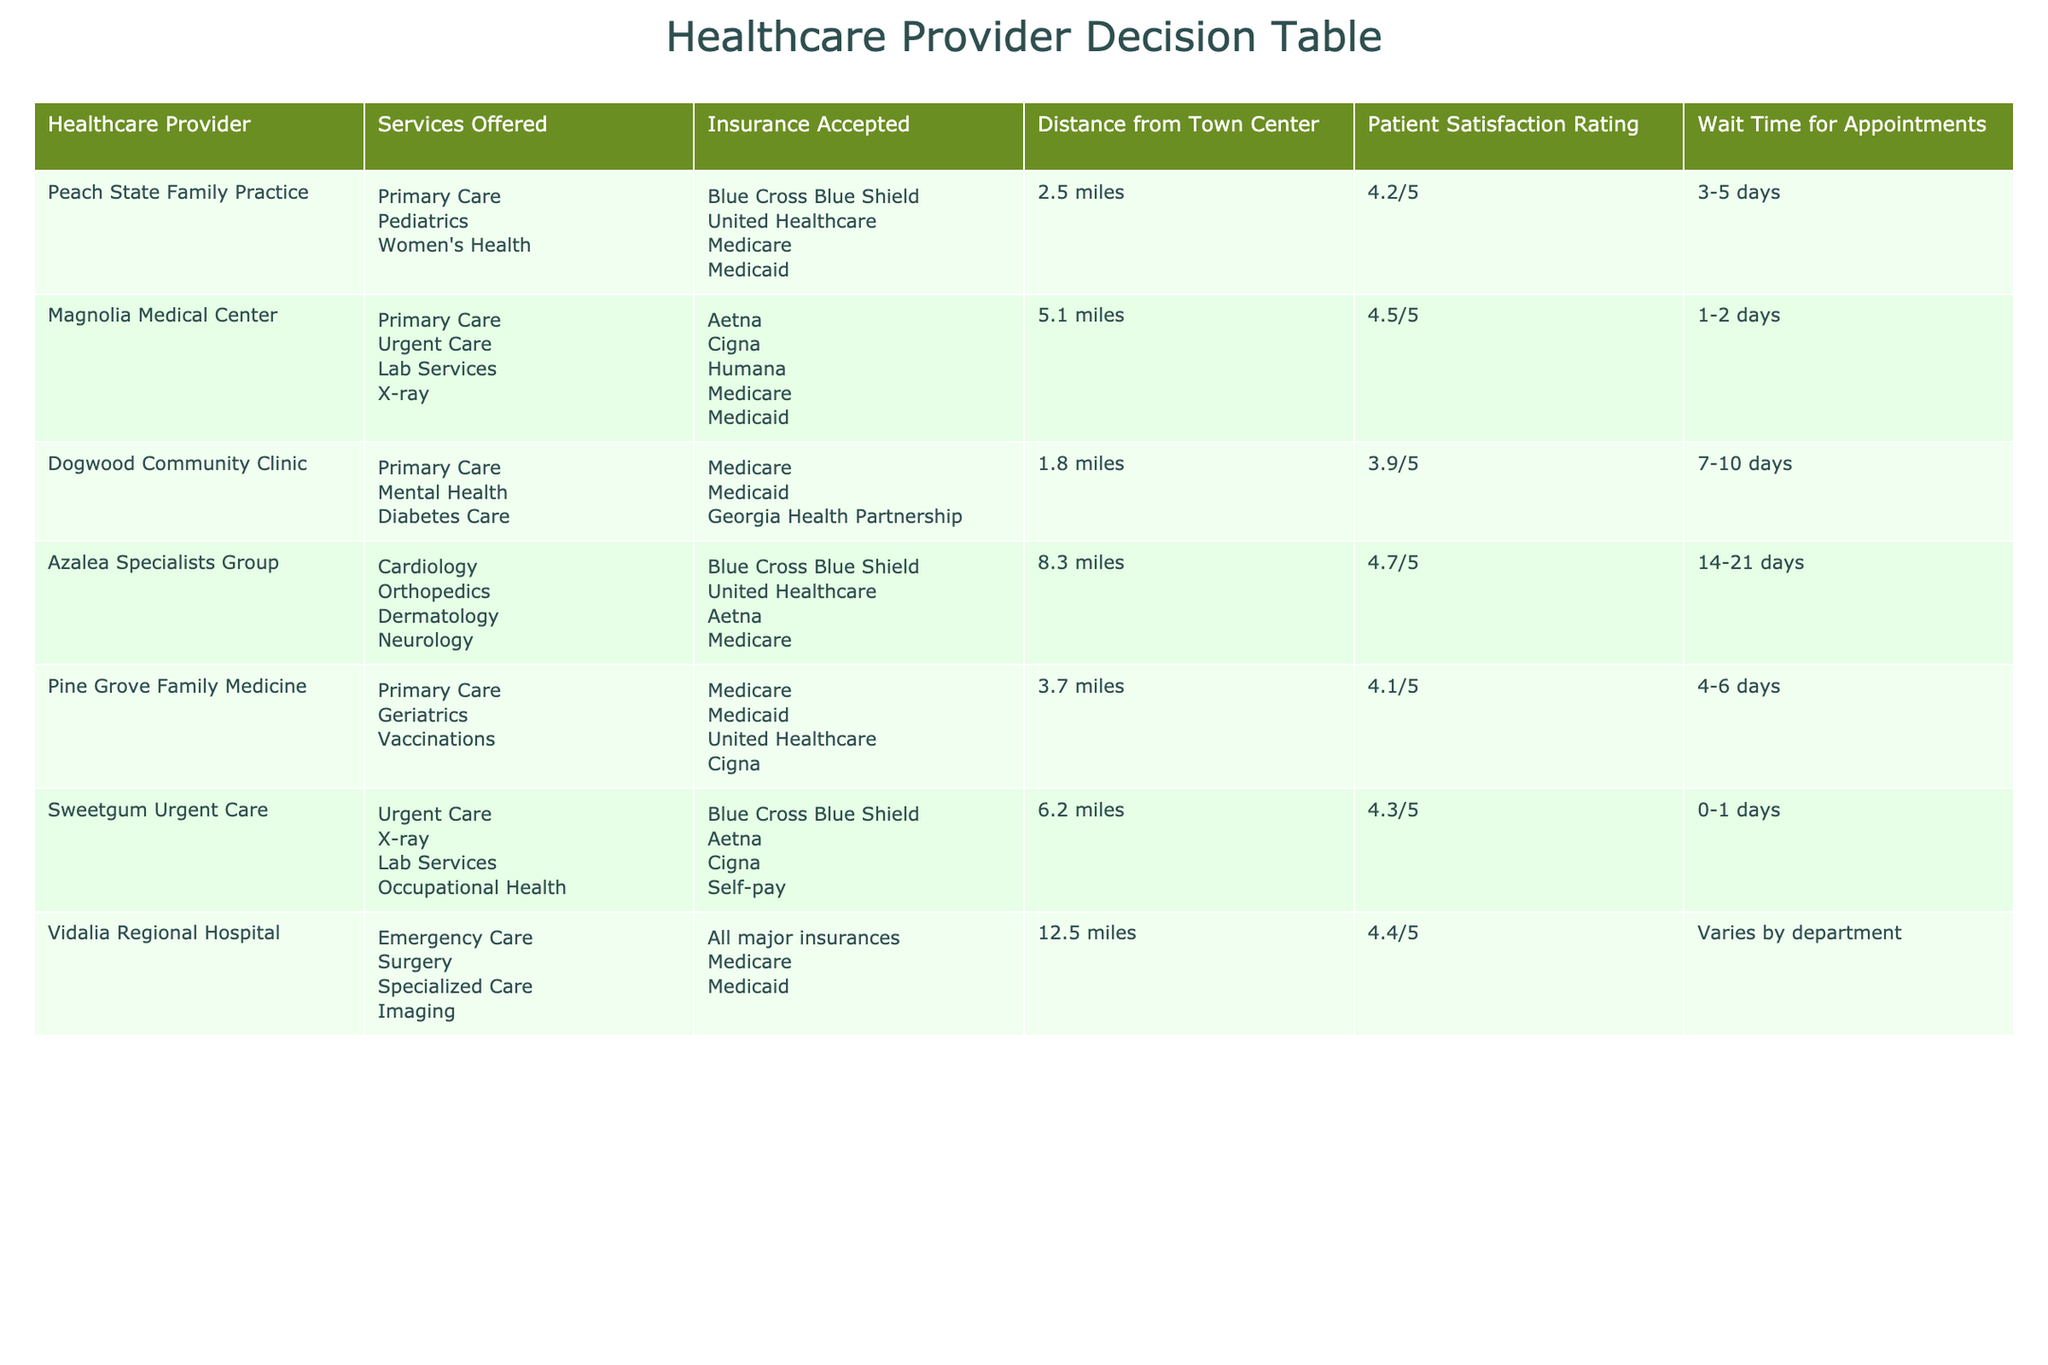What is the distance from Peach State Family Practice to the town center? The table lists the distance from the town center for each healthcare provider. For Peach State Family Practice, the distance is shown as 2.5 miles.
Answer: 2.5 miles Which provider has the highest patient satisfaction rating? The table includes ratings for patient satisfaction. Upon comparing the ratings, Azalea Specialists Group has the highest rating at 4.7/5.
Answer: Azalea Specialists Group How many healthcare providers accept Medicare? By reviewing the 'Insurance Accepted' column, we can count how many providers list Medicare among their accepted insurances. The providers that accept Medicare are: Magnolia Medical Center, Dogwood Community Clinic, Pine Grove Family Medicine, Azalea Specialists Group, Sweetgum Urgent Care, and Vidalia Regional Hospital, totaling 6 providers.
Answer: 6 Is there a provider that offers urgent care services within 5 miles of the town center? To answer this, we check the services offered and the distance from the town center for each provider. Magnolia Medical Center and Sweetgum Urgent Care both offer urgent care services and are located within 5 miles. Thus, the answer is yes.
Answer: Yes What is the average wait time for appointments among the providers? First, identify the wait times from the table: Peach State Family Practice (3-5 days), Magnolia Medical Center (1-2 days), Dogwood Community Clinic (7-10 days), Pine Grove Family Medicine (4-6 days), Sweetgum Urgent Care (0-1 days), and Vidalia Regional Hospital (varies). Estimate the average wait time by taking the midpoint of each range: 4 days, 1.5 days, 8.5 days, 5 days, 0.5 days, and an assumed midpoint (for variability) of 7 days. Add these values: 4 + 1.5 + 8.5 + 5 + 0.5 + 7 = 27.5 days. Divide by the count of providers (6) to get approximately 4.58 days.
Answer: Approximately 4.58 days 